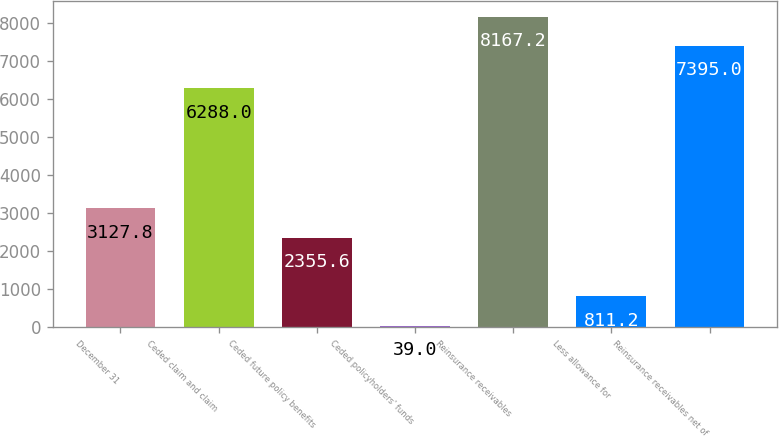Convert chart. <chart><loc_0><loc_0><loc_500><loc_500><bar_chart><fcel>December 31<fcel>Ceded claim and claim<fcel>Ceded future policy benefits<fcel>Ceded policyholders' funds<fcel>Reinsurance receivables<fcel>Less allowance for<fcel>Reinsurance receivables net of<nl><fcel>3127.8<fcel>6288<fcel>2355.6<fcel>39<fcel>8167.2<fcel>811.2<fcel>7395<nl></chart> 